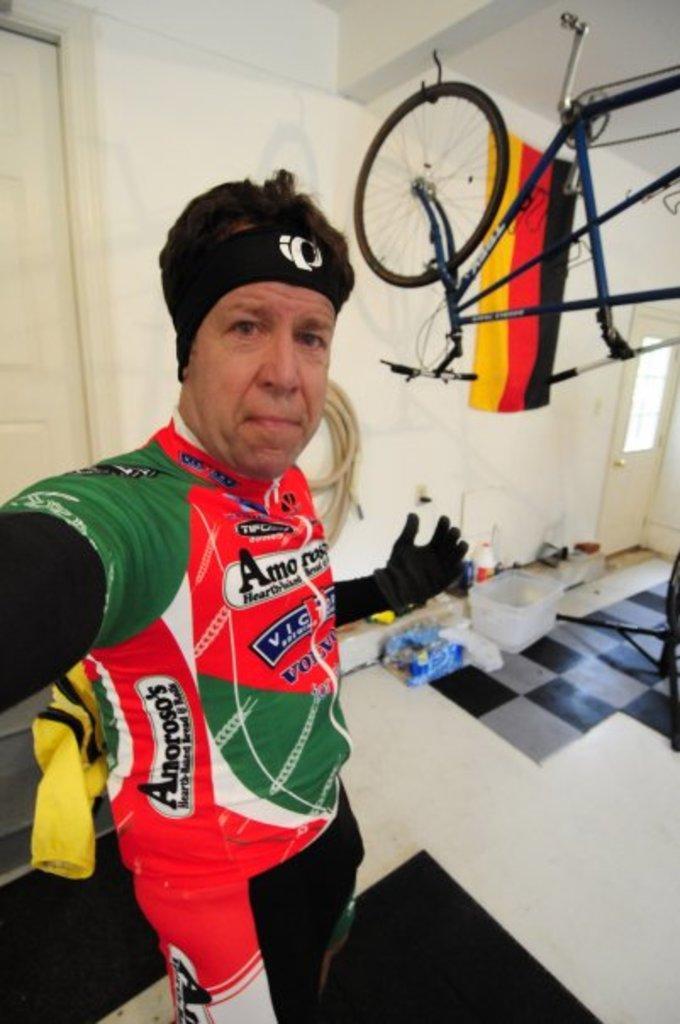How would you summarize this image in a sentence or two? In this image on the left there is a man, he wears a jacket, trouser. At the bottom there is floor on that there are baskets, bottles. At the top there is cycle, flag and wall. 